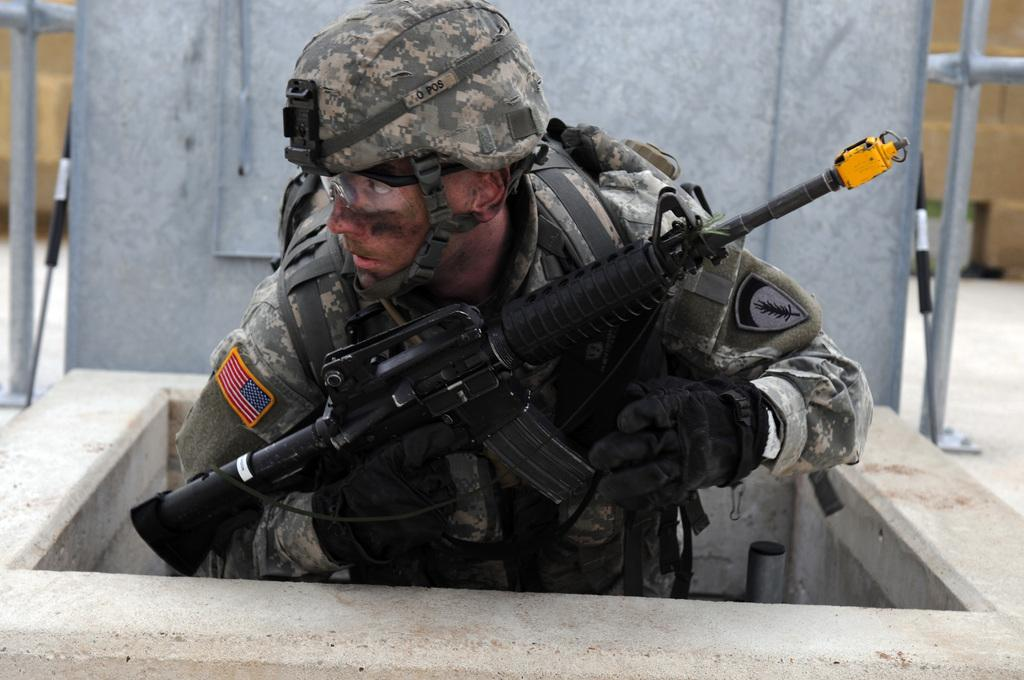What is the person in the image wearing? The person is wearing a uniform and a cap. What is the person holding in the image? The person is holding a gun. What can be seen in the background of the image? There are poles in the image. What type of object is metallic in the image? There is a metallic object in the image. What color is the volleyball in the image? There is no volleyball present in the image. What type of jewel is the person wearing in the image? The person in the image is not wearing any jewelry, let alone a jewel. 